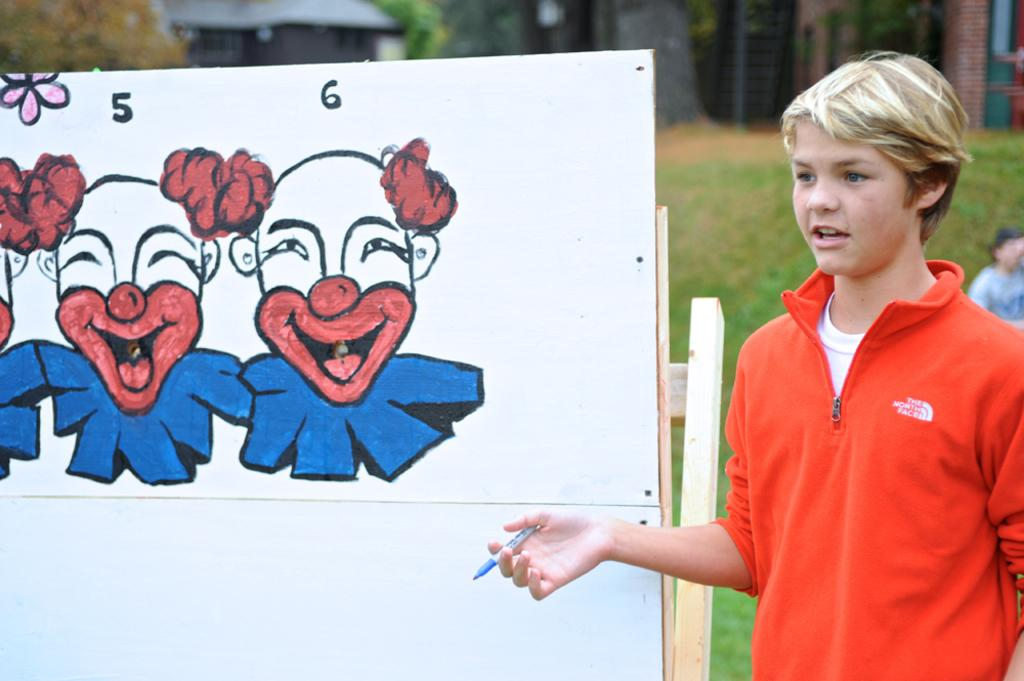What is the main subject of the image? There is a boy standing in the image. What is beside the boy? There is a board with a painting on it beside the boy. What type of natural environment is visible in the image? There are trees visible in the image. What type of man-made structures can be seen in the image? There are buildings in the image. What type of ground surface is present in the image? There is grass in the image. What type of cheese is being used to create the painting on the board? There is no cheese present in the image; the painting on the board is not made of cheese. 